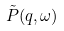<formula> <loc_0><loc_0><loc_500><loc_500>\tilde { P } ( q , \omega )</formula> 